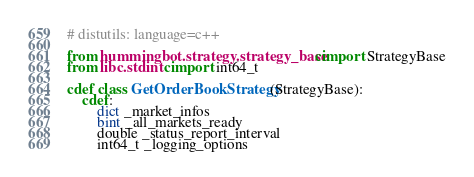<code> <loc_0><loc_0><loc_500><loc_500><_Cython_># distutils: language=c++

from hummingbot.strategy.strategy_base cimport StrategyBase
from libc.stdint cimport int64_t

cdef class GetOrderBookStrategy(StrategyBase):
    cdef:
        dict _market_infos
        bint _all_markets_ready
        double _status_report_interval
        int64_t _logging_options
</code> 